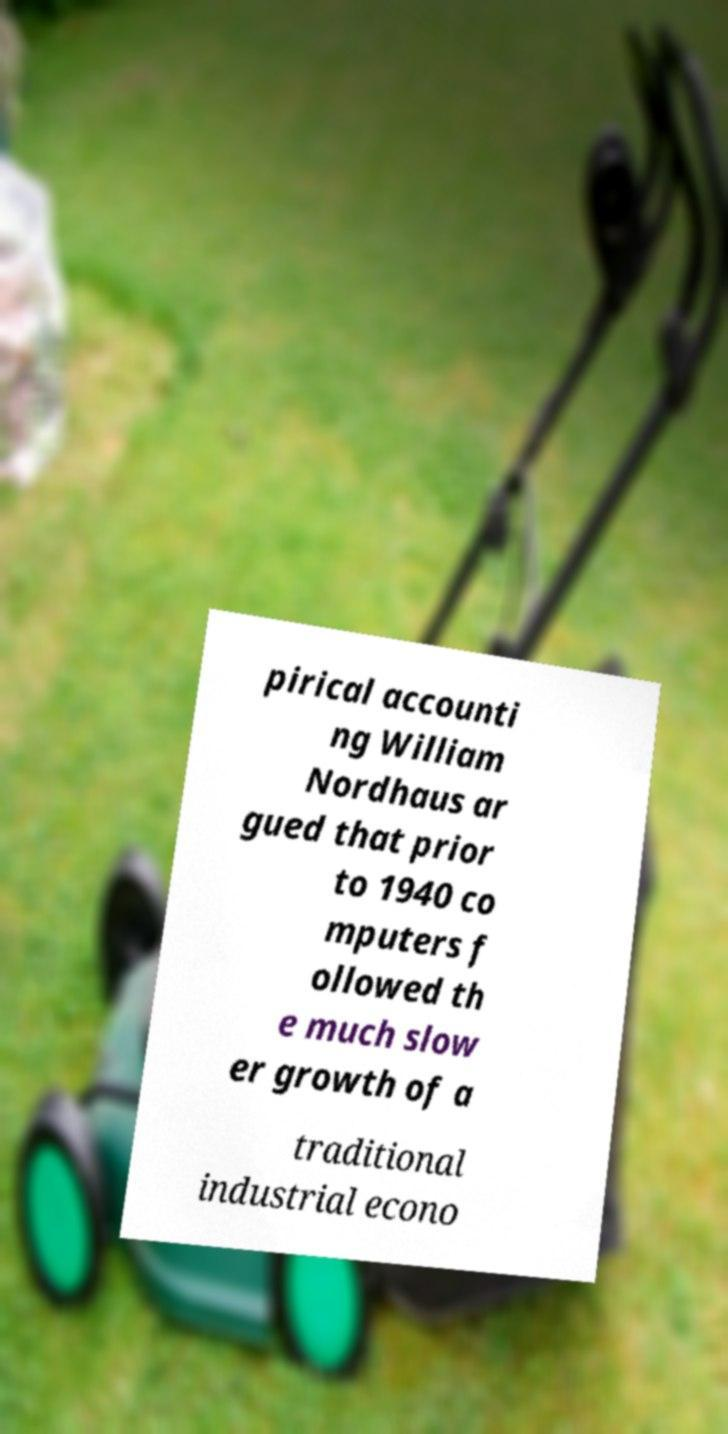Could you extract and type out the text from this image? pirical accounti ng William Nordhaus ar gued that prior to 1940 co mputers f ollowed th e much slow er growth of a traditional industrial econo 